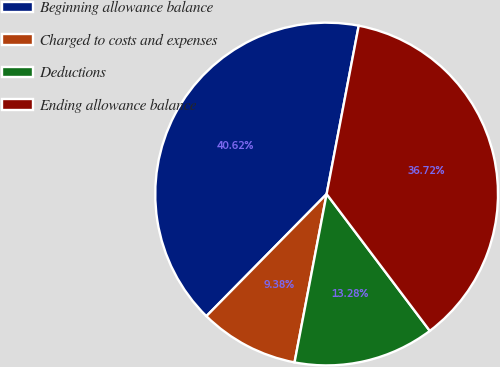Convert chart. <chart><loc_0><loc_0><loc_500><loc_500><pie_chart><fcel>Beginning allowance balance<fcel>Charged to costs and expenses<fcel>Deductions<fcel>Ending allowance balance<nl><fcel>40.62%<fcel>9.38%<fcel>13.28%<fcel>36.72%<nl></chart> 